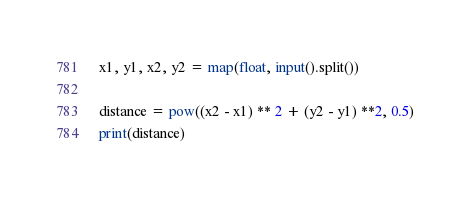<code> <loc_0><loc_0><loc_500><loc_500><_Python_>x1, y1, x2, y2 = map(float, input().split())

distance = pow((x2 - x1) ** 2 + (y2 - y1) **2, 0.5)
print(distance)
</code> 